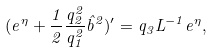<formula> <loc_0><loc_0><loc_500><loc_500>( e ^ { \eta } + \frac { 1 } { 2 } \frac { q _ { 2 } ^ { 2 } } { q _ { 1 } ^ { 2 } } \hat { b } ^ { 2 } ) ^ { \prime } = q _ { 3 } L ^ { - 1 } e ^ { \eta } ,</formula> 